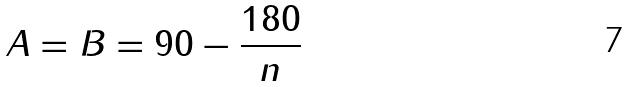<formula> <loc_0><loc_0><loc_500><loc_500>A = B = 9 0 - \frac { 1 8 0 } { n }</formula> 